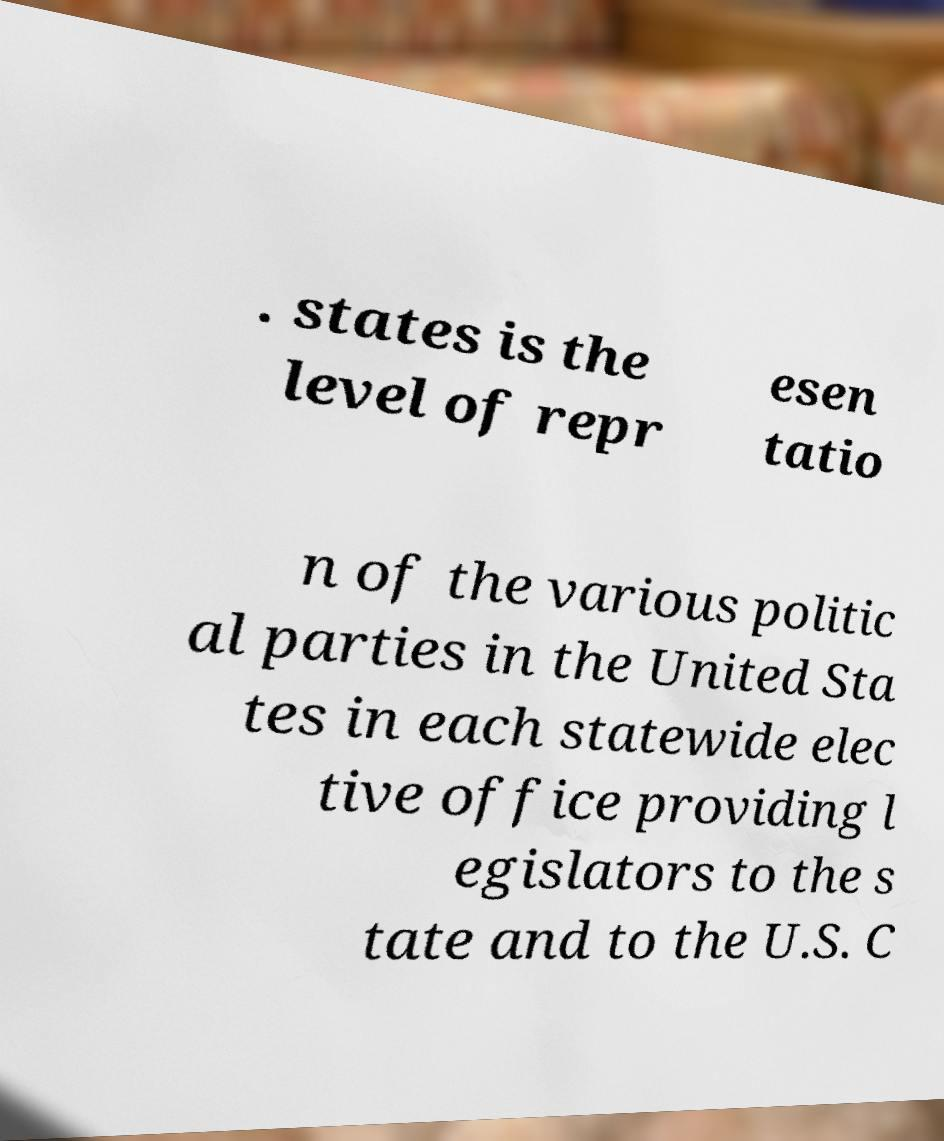Please read and relay the text visible in this image. What does it say? . states is the level of repr esen tatio n of the various politic al parties in the United Sta tes in each statewide elec tive office providing l egislators to the s tate and to the U.S. C 